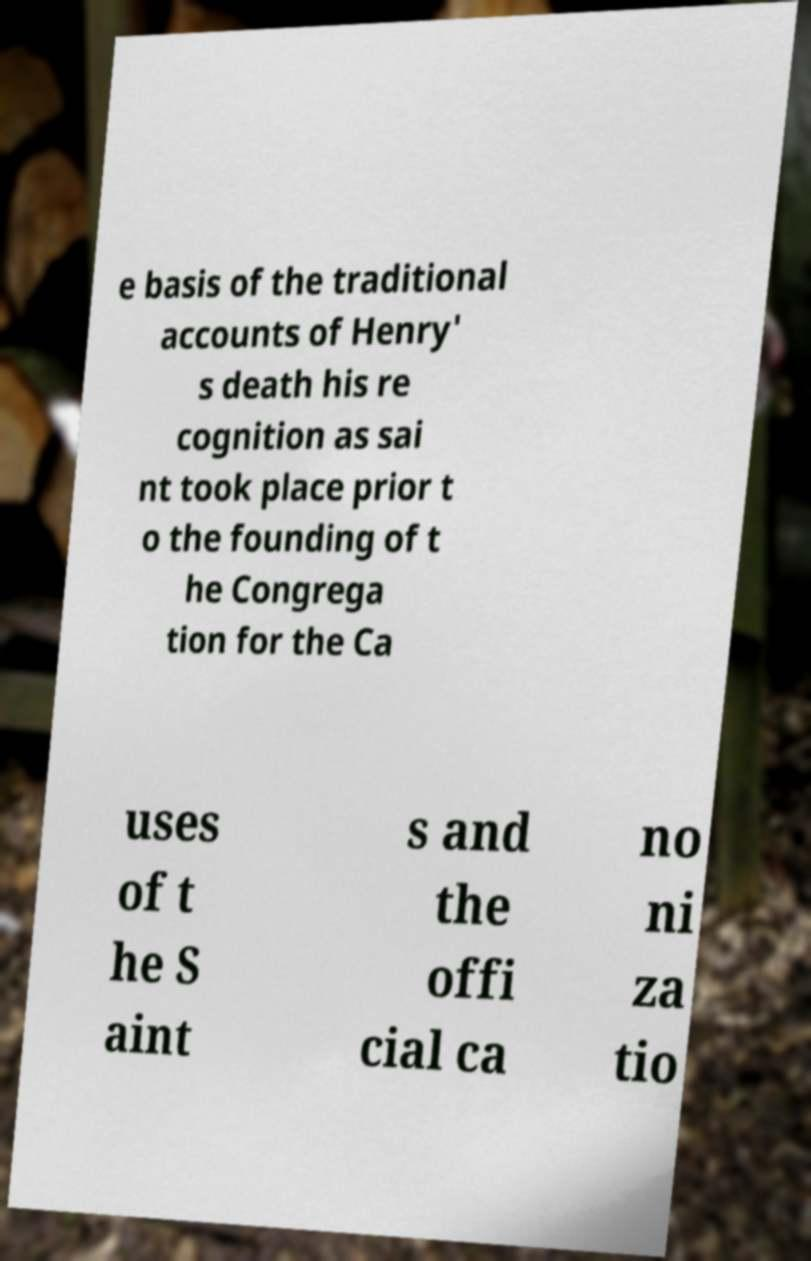What messages or text are displayed in this image? I need them in a readable, typed format. e basis of the traditional accounts of Henry' s death his re cognition as sai nt took place prior t o the founding of t he Congrega tion for the Ca uses of t he S aint s and the offi cial ca no ni za tio 